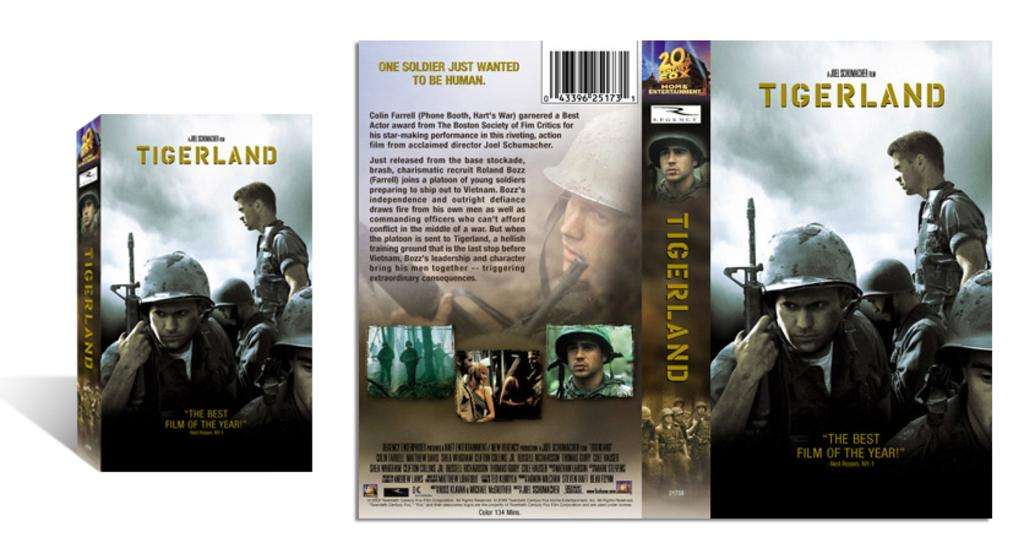Provide a one-sentence caption for the provided image. The movie cover for a movie called Tigerland. 